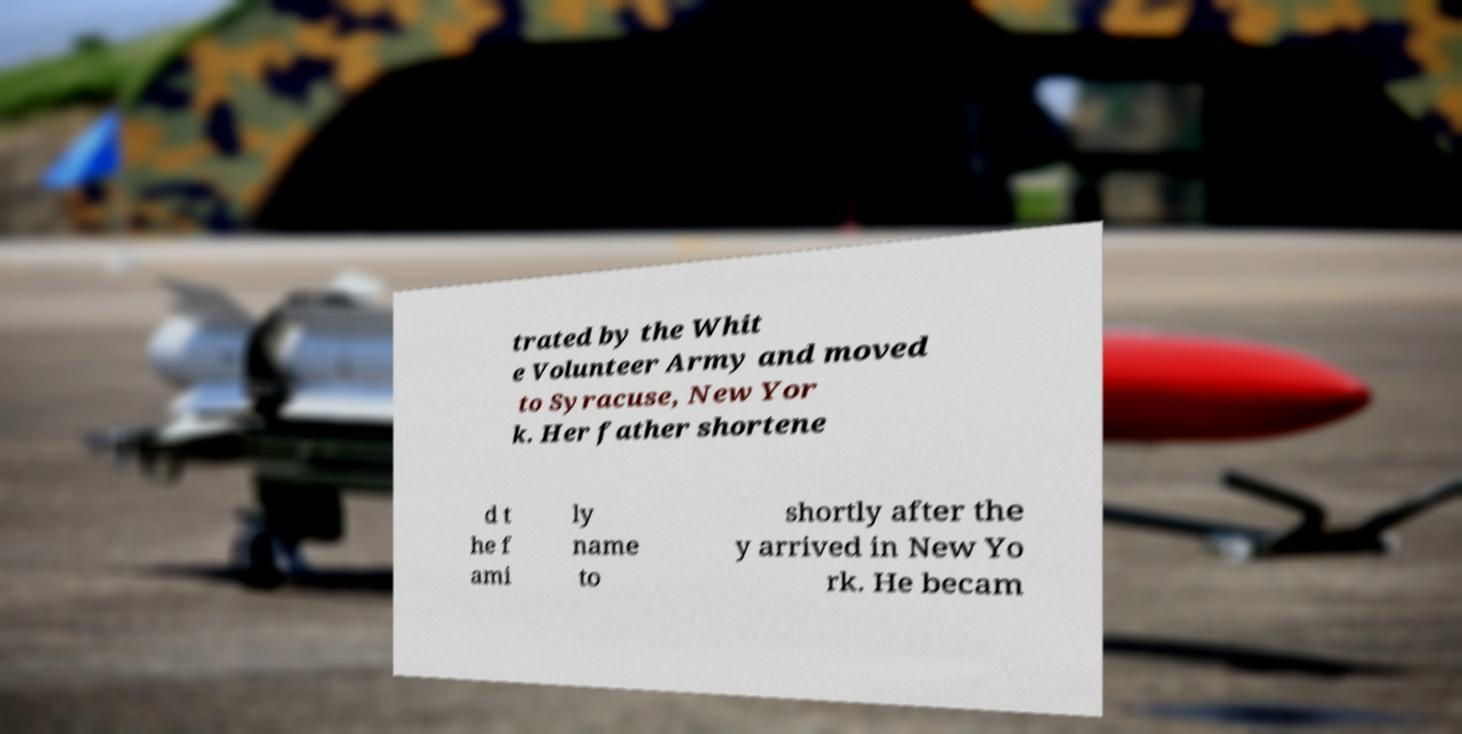Could you assist in decoding the text presented in this image and type it out clearly? trated by the Whit e Volunteer Army and moved to Syracuse, New Yor k. Her father shortene d t he f ami ly name to shortly after the y arrived in New Yo rk. He becam 